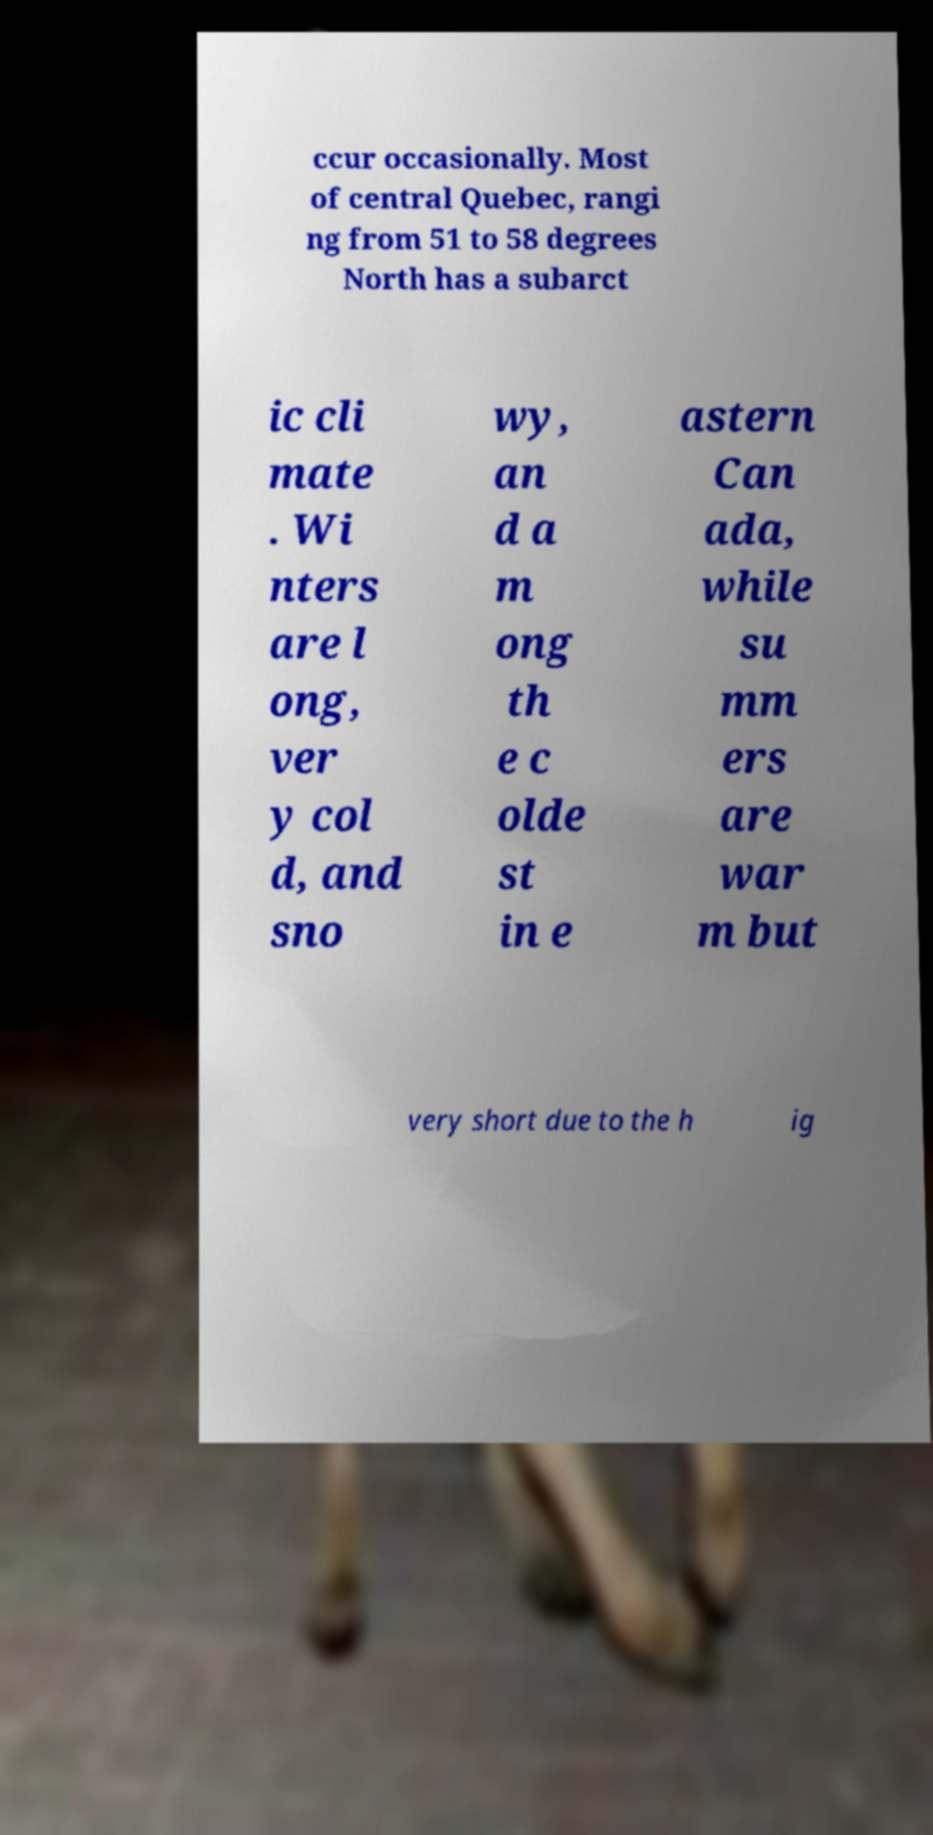Could you assist in decoding the text presented in this image and type it out clearly? ccur occasionally. Most of central Quebec, rangi ng from 51 to 58 degrees North has a subarct ic cli mate . Wi nters are l ong, ver y col d, and sno wy, an d a m ong th e c olde st in e astern Can ada, while su mm ers are war m but very short due to the h ig 